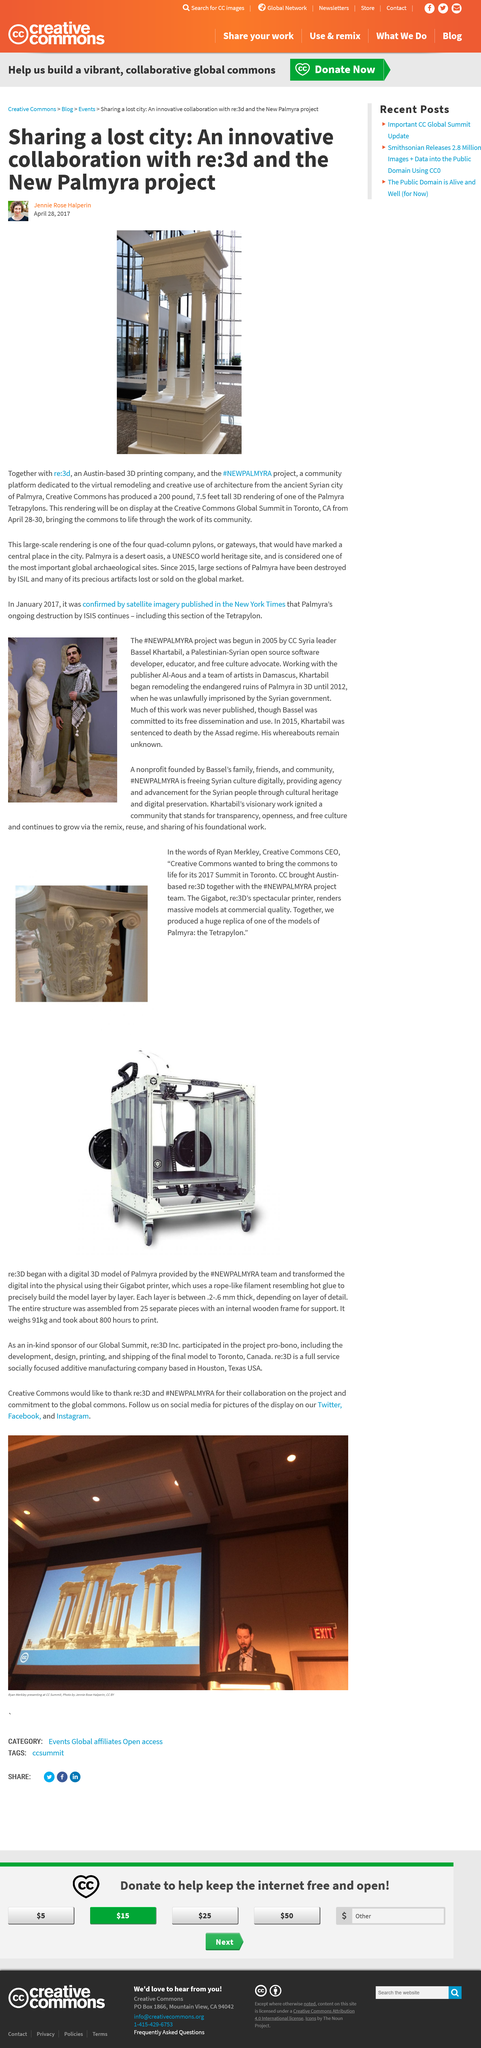Give some essential details in this illustration. The lost city is located in Palmyra, Syria, as stated in the previously mentioned source. The 3D rendering is 7.5 feet tall. The 3D rendering is white. 